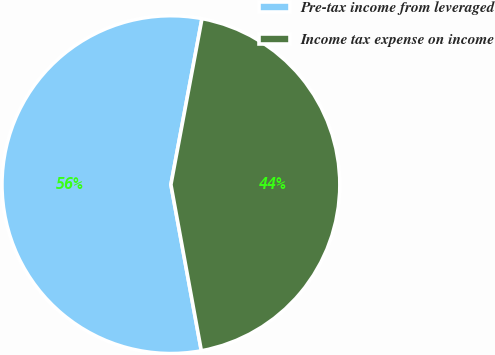Convert chart. <chart><loc_0><loc_0><loc_500><loc_500><pie_chart><fcel>Pre-tax income from leveraged<fcel>Income tax expense on income<nl><fcel>55.83%<fcel>44.17%<nl></chart> 